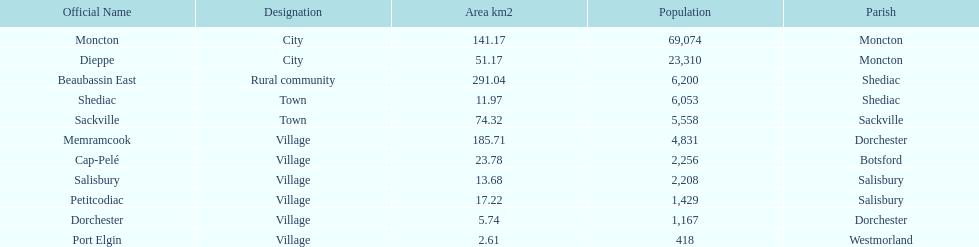Which municipality has the most number of people who reside in it? Moncton. 